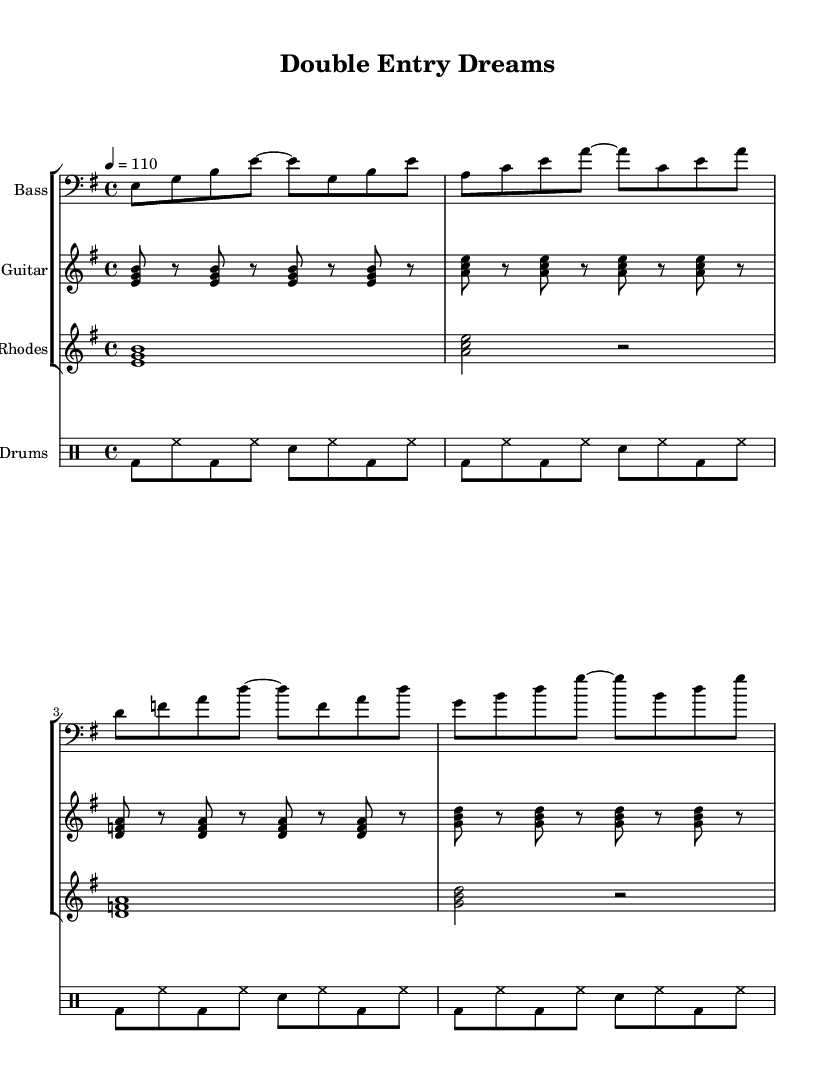What is the key signature of this music? The key signature is E minor, which has one sharp (F#). This can be identified from the key signature marked at the beginning of the sheet music.
Answer: E minor What is the time signature of this piece? The time signature is 4/4, indicating that there are four beats in each measure and the quarter note gets one beat. This is indicated at the beginning of the score.
Answer: 4/4 What is the tempo marking for this piece? The tempo marking is 110 beats per minute, which specifically denotes the speed of the music. This can be seen near the top of the sheet music.
Answer: 110 How many measures are there in the bass line? There are four measures in the bass line, which can be confirmed by counting the groupings divided by the bar lines in the bass staff.
Answer: 4 Which instrument plays the root notes in the chords? The guitar plays the root notes in the chords as it is styled with triads throughout the part for harmonic support. This can be seen by looking at the chord structure in the guitar part.
Answer: Guitar What rhythmic pattern is primarily used in the drums? The primary rhythmic pattern in the drums consists of bass drums accented on the downbeat with hi-hats in between. This rhythm can be analyzed by examining the detailed notation in the drum part.
Answer: Bass and hi-hat What musical style does this piece represent? This piece represents the funk style, which is characterized by strong rhythmic grooves and syncopation. The instrumentation and rhythmic feel confirm its classification as funk music.
Answer: Funk 